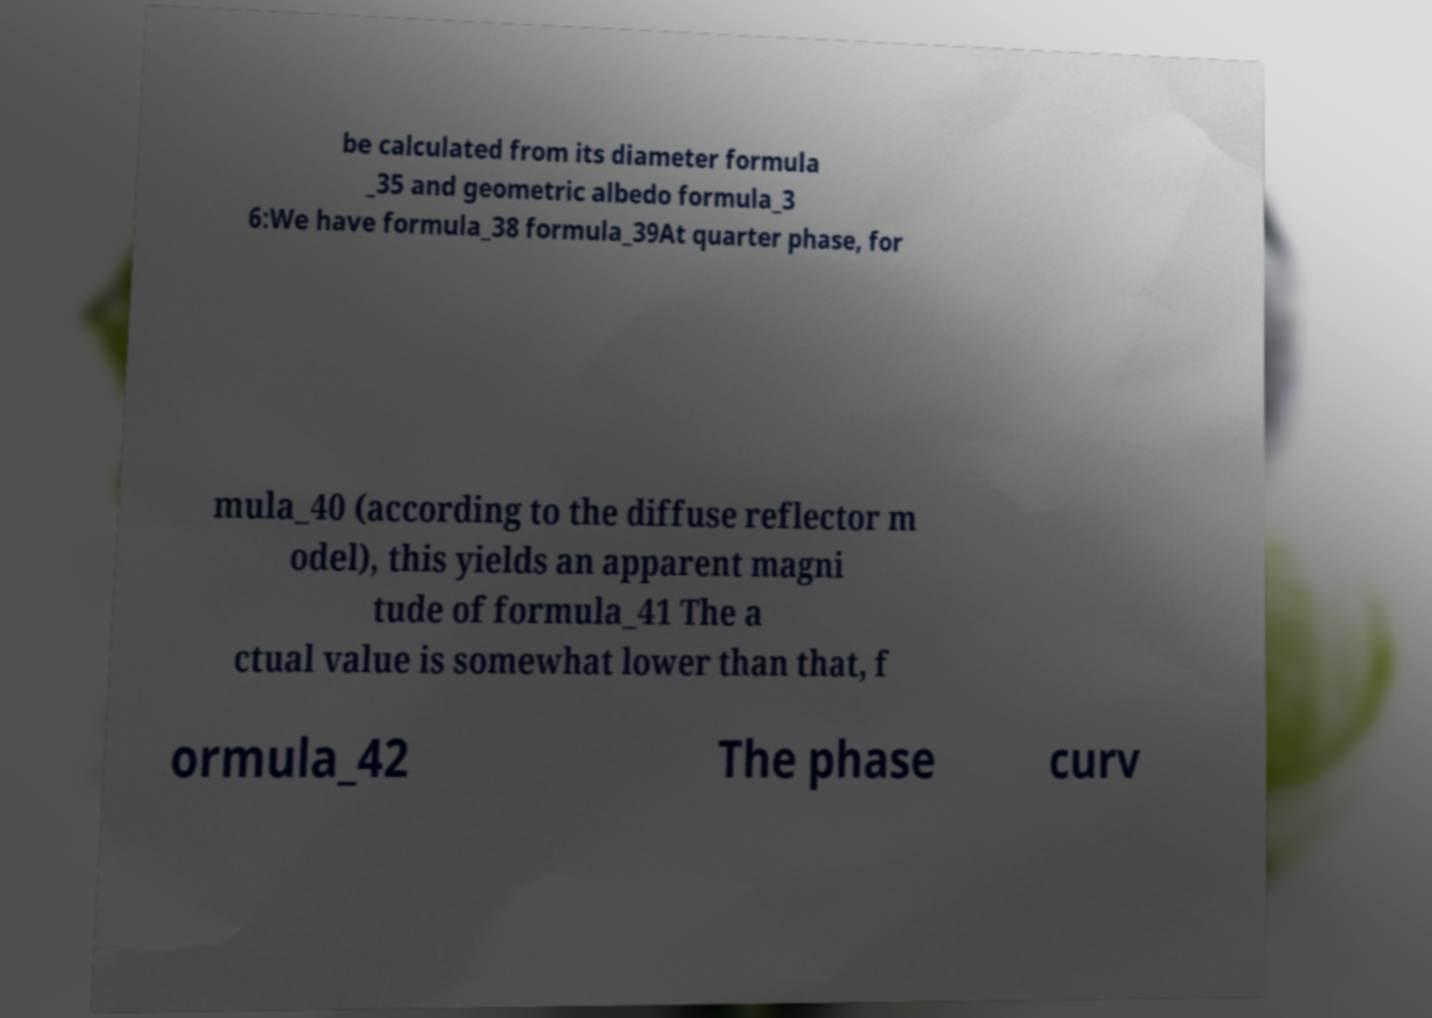Could you assist in decoding the text presented in this image and type it out clearly? be calculated from its diameter formula _35 and geometric albedo formula_3 6:We have formula_38 formula_39At quarter phase, for mula_40 (according to the diffuse reflector m odel), this yields an apparent magni tude of formula_41 The a ctual value is somewhat lower than that, f ormula_42 The phase curv 